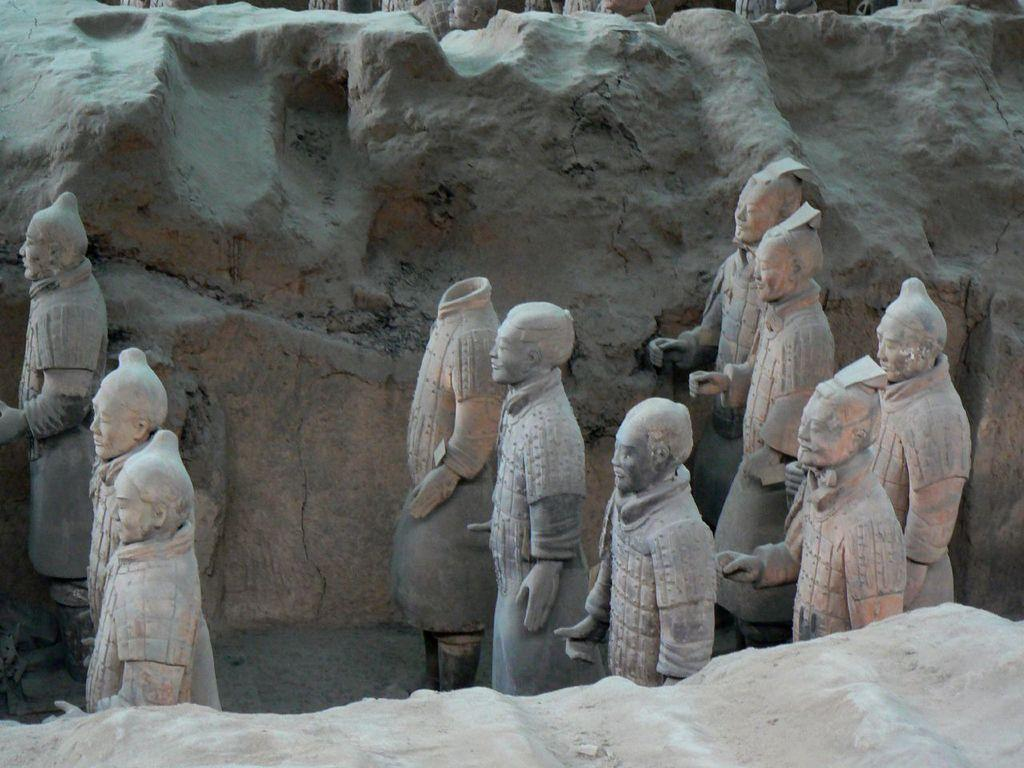What is the main subject in the center of the image? There are sculptures in the center of the image. What can be seen in the background of the image? There are rocks in the background of the image. What type of kettle is used to boil water in the image? There is no kettle present in the image; it features sculptures and rocks. What is located on top of the sculptures in the image? The provided facts do not mention anything being on top of the sculptures, so we cannot answer this question definitively. 